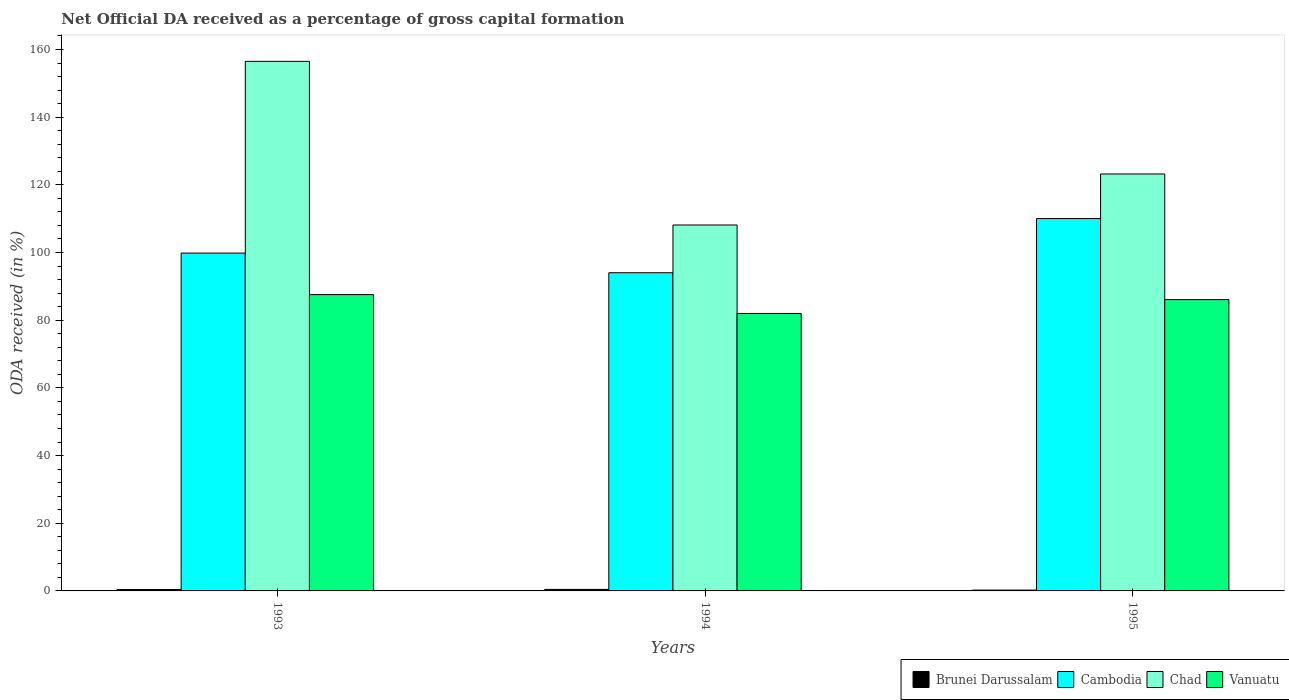How many groups of bars are there?
Your response must be concise. 3. What is the net ODA received in Cambodia in 1993?
Ensure brevity in your answer.  99.83. Across all years, what is the maximum net ODA received in Vanuatu?
Provide a short and direct response. 87.56. Across all years, what is the minimum net ODA received in Chad?
Provide a short and direct response. 108.13. In which year was the net ODA received in Vanuatu maximum?
Keep it short and to the point. 1993. What is the total net ODA received in Chad in the graph?
Provide a short and direct response. 387.83. What is the difference between the net ODA received in Vanuatu in 1993 and that in 1995?
Keep it short and to the point. 1.48. What is the difference between the net ODA received in Cambodia in 1993 and the net ODA received in Vanuatu in 1994?
Ensure brevity in your answer.  17.84. What is the average net ODA received in Vanuatu per year?
Make the answer very short. 85.21. In the year 1994, what is the difference between the net ODA received in Vanuatu and net ODA received in Chad?
Offer a terse response. -26.14. What is the ratio of the net ODA received in Vanuatu in 1993 to that in 1994?
Provide a succinct answer. 1.07. Is the net ODA received in Cambodia in 1993 less than that in 1995?
Offer a very short reply. Yes. What is the difference between the highest and the second highest net ODA received in Cambodia?
Offer a terse response. 10.2. What is the difference between the highest and the lowest net ODA received in Vanuatu?
Make the answer very short. 5.57. Is the sum of the net ODA received in Cambodia in 1993 and 1994 greater than the maximum net ODA received in Chad across all years?
Keep it short and to the point. Yes. Is it the case that in every year, the sum of the net ODA received in Chad and net ODA received in Cambodia is greater than the sum of net ODA received in Vanuatu and net ODA received in Brunei Darussalam?
Ensure brevity in your answer.  No. What does the 4th bar from the left in 1994 represents?
Your response must be concise. Vanuatu. What does the 1st bar from the right in 1994 represents?
Ensure brevity in your answer.  Vanuatu. Is it the case that in every year, the sum of the net ODA received in Vanuatu and net ODA received in Brunei Darussalam is greater than the net ODA received in Chad?
Provide a succinct answer. No. How many years are there in the graph?
Keep it short and to the point. 3. Are the values on the major ticks of Y-axis written in scientific E-notation?
Your response must be concise. No. Does the graph contain any zero values?
Offer a terse response. No. How are the legend labels stacked?
Your answer should be very brief. Horizontal. What is the title of the graph?
Make the answer very short. Net Official DA received as a percentage of gross capital formation. What is the label or title of the Y-axis?
Give a very brief answer. ODA received (in %). What is the ODA received (in %) of Brunei Darussalam in 1993?
Offer a very short reply. 0.42. What is the ODA received (in %) in Cambodia in 1993?
Your response must be concise. 99.83. What is the ODA received (in %) in Chad in 1993?
Keep it short and to the point. 156.49. What is the ODA received (in %) in Vanuatu in 1993?
Provide a succinct answer. 87.56. What is the ODA received (in %) of Brunei Darussalam in 1994?
Ensure brevity in your answer.  0.45. What is the ODA received (in %) of Cambodia in 1994?
Offer a terse response. 94.03. What is the ODA received (in %) of Chad in 1994?
Your answer should be compact. 108.13. What is the ODA received (in %) in Vanuatu in 1994?
Provide a succinct answer. 81.99. What is the ODA received (in %) in Brunei Darussalam in 1995?
Your answer should be compact. 0.25. What is the ODA received (in %) in Cambodia in 1995?
Provide a short and direct response. 110.03. What is the ODA received (in %) of Chad in 1995?
Keep it short and to the point. 123.21. What is the ODA received (in %) in Vanuatu in 1995?
Your response must be concise. 86.09. Across all years, what is the maximum ODA received (in %) of Brunei Darussalam?
Provide a succinct answer. 0.45. Across all years, what is the maximum ODA received (in %) in Cambodia?
Give a very brief answer. 110.03. Across all years, what is the maximum ODA received (in %) of Chad?
Keep it short and to the point. 156.49. Across all years, what is the maximum ODA received (in %) in Vanuatu?
Your response must be concise. 87.56. Across all years, what is the minimum ODA received (in %) of Brunei Darussalam?
Give a very brief answer. 0.25. Across all years, what is the minimum ODA received (in %) in Cambodia?
Offer a terse response. 94.03. Across all years, what is the minimum ODA received (in %) in Chad?
Provide a short and direct response. 108.13. Across all years, what is the minimum ODA received (in %) in Vanuatu?
Offer a very short reply. 81.99. What is the total ODA received (in %) of Brunei Darussalam in the graph?
Provide a short and direct response. 1.11. What is the total ODA received (in %) in Cambodia in the graph?
Keep it short and to the point. 303.89. What is the total ODA received (in %) in Chad in the graph?
Provide a succinct answer. 387.83. What is the total ODA received (in %) of Vanuatu in the graph?
Provide a succinct answer. 255.64. What is the difference between the ODA received (in %) in Brunei Darussalam in 1993 and that in 1994?
Your response must be concise. -0.03. What is the difference between the ODA received (in %) of Cambodia in 1993 and that in 1994?
Offer a very short reply. 5.8. What is the difference between the ODA received (in %) in Chad in 1993 and that in 1994?
Your answer should be very brief. 48.36. What is the difference between the ODA received (in %) in Vanuatu in 1993 and that in 1994?
Provide a short and direct response. 5.57. What is the difference between the ODA received (in %) in Brunei Darussalam in 1993 and that in 1995?
Your answer should be very brief. 0.17. What is the difference between the ODA received (in %) in Cambodia in 1993 and that in 1995?
Offer a very short reply. -10.2. What is the difference between the ODA received (in %) in Chad in 1993 and that in 1995?
Offer a terse response. 33.28. What is the difference between the ODA received (in %) of Vanuatu in 1993 and that in 1995?
Provide a short and direct response. 1.48. What is the difference between the ODA received (in %) in Brunei Darussalam in 1994 and that in 1995?
Make the answer very short. 0.2. What is the difference between the ODA received (in %) in Cambodia in 1994 and that in 1995?
Ensure brevity in your answer.  -16. What is the difference between the ODA received (in %) of Chad in 1994 and that in 1995?
Your answer should be compact. -15.07. What is the difference between the ODA received (in %) in Vanuatu in 1994 and that in 1995?
Give a very brief answer. -4.09. What is the difference between the ODA received (in %) of Brunei Darussalam in 1993 and the ODA received (in %) of Cambodia in 1994?
Offer a terse response. -93.61. What is the difference between the ODA received (in %) in Brunei Darussalam in 1993 and the ODA received (in %) in Chad in 1994?
Keep it short and to the point. -107.72. What is the difference between the ODA received (in %) in Brunei Darussalam in 1993 and the ODA received (in %) in Vanuatu in 1994?
Your answer should be very brief. -81.58. What is the difference between the ODA received (in %) in Cambodia in 1993 and the ODA received (in %) in Chad in 1994?
Make the answer very short. -8.3. What is the difference between the ODA received (in %) in Cambodia in 1993 and the ODA received (in %) in Vanuatu in 1994?
Your answer should be very brief. 17.84. What is the difference between the ODA received (in %) of Chad in 1993 and the ODA received (in %) of Vanuatu in 1994?
Keep it short and to the point. 74.5. What is the difference between the ODA received (in %) in Brunei Darussalam in 1993 and the ODA received (in %) in Cambodia in 1995?
Provide a short and direct response. -109.61. What is the difference between the ODA received (in %) of Brunei Darussalam in 1993 and the ODA received (in %) of Chad in 1995?
Provide a succinct answer. -122.79. What is the difference between the ODA received (in %) of Brunei Darussalam in 1993 and the ODA received (in %) of Vanuatu in 1995?
Provide a succinct answer. -85.67. What is the difference between the ODA received (in %) of Cambodia in 1993 and the ODA received (in %) of Chad in 1995?
Offer a very short reply. -23.38. What is the difference between the ODA received (in %) in Cambodia in 1993 and the ODA received (in %) in Vanuatu in 1995?
Keep it short and to the point. 13.75. What is the difference between the ODA received (in %) of Chad in 1993 and the ODA received (in %) of Vanuatu in 1995?
Provide a short and direct response. 70.4. What is the difference between the ODA received (in %) of Brunei Darussalam in 1994 and the ODA received (in %) of Cambodia in 1995?
Ensure brevity in your answer.  -109.58. What is the difference between the ODA received (in %) in Brunei Darussalam in 1994 and the ODA received (in %) in Chad in 1995?
Keep it short and to the point. -122.76. What is the difference between the ODA received (in %) of Brunei Darussalam in 1994 and the ODA received (in %) of Vanuatu in 1995?
Give a very brief answer. -85.64. What is the difference between the ODA received (in %) in Cambodia in 1994 and the ODA received (in %) in Chad in 1995?
Your answer should be compact. -29.18. What is the difference between the ODA received (in %) of Cambodia in 1994 and the ODA received (in %) of Vanuatu in 1995?
Your response must be concise. 7.94. What is the difference between the ODA received (in %) in Chad in 1994 and the ODA received (in %) in Vanuatu in 1995?
Offer a very short reply. 22.05. What is the average ODA received (in %) in Brunei Darussalam per year?
Provide a succinct answer. 0.37. What is the average ODA received (in %) of Cambodia per year?
Make the answer very short. 101.3. What is the average ODA received (in %) in Chad per year?
Your response must be concise. 129.28. What is the average ODA received (in %) in Vanuatu per year?
Provide a short and direct response. 85.21. In the year 1993, what is the difference between the ODA received (in %) in Brunei Darussalam and ODA received (in %) in Cambodia?
Offer a very short reply. -99.42. In the year 1993, what is the difference between the ODA received (in %) of Brunei Darussalam and ODA received (in %) of Chad?
Give a very brief answer. -156.07. In the year 1993, what is the difference between the ODA received (in %) in Brunei Darussalam and ODA received (in %) in Vanuatu?
Your answer should be very brief. -87.15. In the year 1993, what is the difference between the ODA received (in %) of Cambodia and ODA received (in %) of Chad?
Provide a succinct answer. -56.66. In the year 1993, what is the difference between the ODA received (in %) of Cambodia and ODA received (in %) of Vanuatu?
Your response must be concise. 12.27. In the year 1993, what is the difference between the ODA received (in %) of Chad and ODA received (in %) of Vanuatu?
Your response must be concise. 68.93. In the year 1994, what is the difference between the ODA received (in %) in Brunei Darussalam and ODA received (in %) in Cambodia?
Ensure brevity in your answer.  -93.58. In the year 1994, what is the difference between the ODA received (in %) of Brunei Darussalam and ODA received (in %) of Chad?
Your response must be concise. -107.68. In the year 1994, what is the difference between the ODA received (in %) of Brunei Darussalam and ODA received (in %) of Vanuatu?
Your response must be concise. -81.54. In the year 1994, what is the difference between the ODA received (in %) of Cambodia and ODA received (in %) of Chad?
Your response must be concise. -14.11. In the year 1994, what is the difference between the ODA received (in %) of Cambodia and ODA received (in %) of Vanuatu?
Keep it short and to the point. 12.03. In the year 1994, what is the difference between the ODA received (in %) of Chad and ODA received (in %) of Vanuatu?
Provide a succinct answer. 26.14. In the year 1995, what is the difference between the ODA received (in %) of Brunei Darussalam and ODA received (in %) of Cambodia?
Provide a short and direct response. -109.78. In the year 1995, what is the difference between the ODA received (in %) of Brunei Darussalam and ODA received (in %) of Chad?
Offer a terse response. -122.96. In the year 1995, what is the difference between the ODA received (in %) in Brunei Darussalam and ODA received (in %) in Vanuatu?
Provide a succinct answer. -85.84. In the year 1995, what is the difference between the ODA received (in %) in Cambodia and ODA received (in %) in Chad?
Offer a very short reply. -13.18. In the year 1995, what is the difference between the ODA received (in %) of Cambodia and ODA received (in %) of Vanuatu?
Offer a terse response. 23.94. In the year 1995, what is the difference between the ODA received (in %) of Chad and ODA received (in %) of Vanuatu?
Give a very brief answer. 37.12. What is the ratio of the ODA received (in %) of Brunei Darussalam in 1993 to that in 1994?
Offer a terse response. 0.93. What is the ratio of the ODA received (in %) of Cambodia in 1993 to that in 1994?
Your answer should be very brief. 1.06. What is the ratio of the ODA received (in %) of Chad in 1993 to that in 1994?
Your answer should be very brief. 1.45. What is the ratio of the ODA received (in %) of Vanuatu in 1993 to that in 1994?
Ensure brevity in your answer.  1.07. What is the ratio of the ODA received (in %) of Brunei Darussalam in 1993 to that in 1995?
Your response must be concise. 1.68. What is the ratio of the ODA received (in %) in Cambodia in 1993 to that in 1995?
Offer a very short reply. 0.91. What is the ratio of the ODA received (in %) of Chad in 1993 to that in 1995?
Give a very brief answer. 1.27. What is the ratio of the ODA received (in %) of Vanuatu in 1993 to that in 1995?
Your answer should be compact. 1.02. What is the ratio of the ODA received (in %) of Brunei Darussalam in 1994 to that in 1995?
Your response must be concise. 1.82. What is the ratio of the ODA received (in %) of Cambodia in 1994 to that in 1995?
Provide a succinct answer. 0.85. What is the ratio of the ODA received (in %) in Chad in 1994 to that in 1995?
Your answer should be very brief. 0.88. What is the ratio of the ODA received (in %) in Vanuatu in 1994 to that in 1995?
Your answer should be compact. 0.95. What is the difference between the highest and the second highest ODA received (in %) of Brunei Darussalam?
Your response must be concise. 0.03. What is the difference between the highest and the second highest ODA received (in %) of Cambodia?
Ensure brevity in your answer.  10.2. What is the difference between the highest and the second highest ODA received (in %) in Chad?
Your response must be concise. 33.28. What is the difference between the highest and the second highest ODA received (in %) in Vanuatu?
Ensure brevity in your answer.  1.48. What is the difference between the highest and the lowest ODA received (in %) in Brunei Darussalam?
Keep it short and to the point. 0.2. What is the difference between the highest and the lowest ODA received (in %) of Cambodia?
Offer a very short reply. 16. What is the difference between the highest and the lowest ODA received (in %) in Chad?
Offer a very short reply. 48.36. What is the difference between the highest and the lowest ODA received (in %) in Vanuatu?
Offer a terse response. 5.57. 